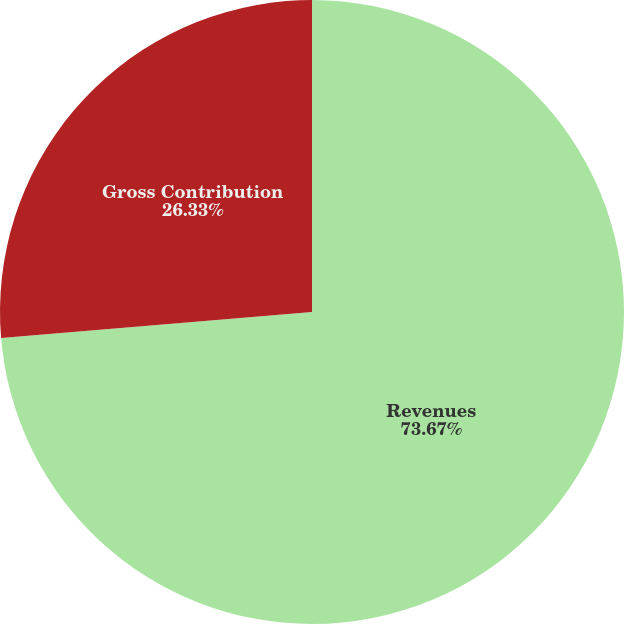Convert chart. <chart><loc_0><loc_0><loc_500><loc_500><pie_chart><fcel>Revenues<fcel>Gross Contribution<nl><fcel>73.67%<fcel>26.33%<nl></chart> 